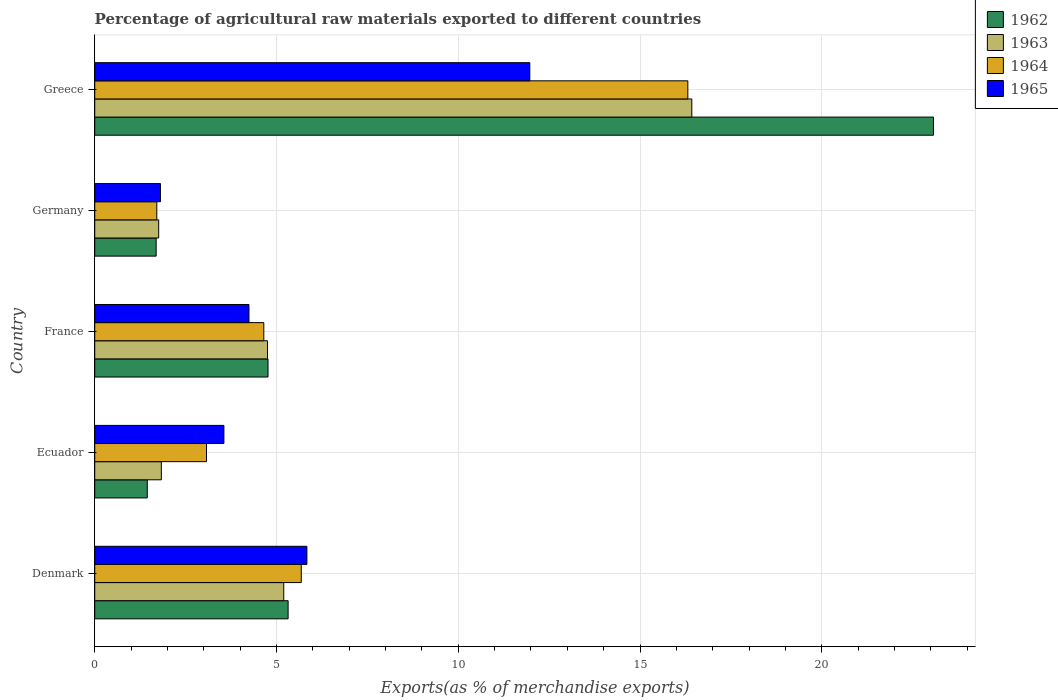How many groups of bars are there?
Give a very brief answer. 5. Are the number of bars on each tick of the Y-axis equal?
Provide a short and direct response. Yes. How many bars are there on the 5th tick from the bottom?
Keep it short and to the point. 4. In how many cases, is the number of bars for a given country not equal to the number of legend labels?
Your answer should be very brief. 0. What is the percentage of exports to different countries in 1965 in Ecuador?
Your answer should be very brief. 3.55. Across all countries, what is the maximum percentage of exports to different countries in 1962?
Offer a very short reply. 23.07. Across all countries, what is the minimum percentage of exports to different countries in 1965?
Your answer should be very brief. 1.81. In which country was the percentage of exports to different countries in 1964 maximum?
Provide a short and direct response. Greece. What is the total percentage of exports to different countries in 1964 in the graph?
Your answer should be very brief. 31.43. What is the difference between the percentage of exports to different countries in 1964 in Denmark and that in Ecuador?
Ensure brevity in your answer.  2.61. What is the difference between the percentage of exports to different countries in 1965 in France and the percentage of exports to different countries in 1964 in Germany?
Ensure brevity in your answer.  2.54. What is the average percentage of exports to different countries in 1965 per country?
Offer a terse response. 5.48. What is the difference between the percentage of exports to different countries in 1964 and percentage of exports to different countries in 1962 in France?
Ensure brevity in your answer.  -0.12. What is the ratio of the percentage of exports to different countries in 1964 in France to that in Germany?
Your response must be concise. 2.72. Is the percentage of exports to different countries in 1965 in Denmark less than that in France?
Provide a succinct answer. No. What is the difference between the highest and the second highest percentage of exports to different countries in 1965?
Provide a short and direct response. 6.13. What is the difference between the highest and the lowest percentage of exports to different countries in 1965?
Ensure brevity in your answer.  10.16. What does the 2nd bar from the top in Greece represents?
Your response must be concise. 1964. How many bars are there?
Offer a terse response. 20. Are all the bars in the graph horizontal?
Ensure brevity in your answer.  Yes. Does the graph contain any zero values?
Offer a very short reply. No. Does the graph contain grids?
Your answer should be compact. Yes. How many legend labels are there?
Keep it short and to the point. 4. How are the legend labels stacked?
Your answer should be very brief. Vertical. What is the title of the graph?
Offer a terse response. Percentage of agricultural raw materials exported to different countries. What is the label or title of the X-axis?
Offer a terse response. Exports(as % of merchandise exports). What is the label or title of the Y-axis?
Offer a terse response. Country. What is the Exports(as % of merchandise exports) of 1962 in Denmark?
Offer a terse response. 5.32. What is the Exports(as % of merchandise exports) in 1963 in Denmark?
Your response must be concise. 5.2. What is the Exports(as % of merchandise exports) in 1964 in Denmark?
Make the answer very short. 5.68. What is the Exports(as % of merchandise exports) in 1965 in Denmark?
Keep it short and to the point. 5.84. What is the Exports(as % of merchandise exports) of 1962 in Ecuador?
Make the answer very short. 1.45. What is the Exports(as % of merchandise exports) in 1963 in Ecuador?
Your answer should be very brief. 1.83. What is the Exports(as % of merchandise exports) of 1964 in Ecuador?
Keep it short and to the point. 3.07. What is the Exports(as % of merchandise exports) of 1965 in Ecuador?
Keep it short and to the point. 3.55. What is the Exports(as % of merchandise exports) in 1962 in France?
Provide a short and direct response. 4.77. What is the Exports(as % of merchandise exports) in 1963 in France?
Ensure brevity in your answer.  4.75. What is the Exports(as % of merchandise exports) of 1964 in France?
Make the answer very short. 4.65. What is the Exports(as % of merchandise exports) in 1965 in France?
Offer a very short reply. 4.24. What is the Exports(as % of merchandise exports) of 1962 in Germany?
Provide a short and direct response. 1.69. What is the Exports(as % of merchandise exports) in 1963 in Germany?
Your answer should be very brief. 1.76. What is the Exports(as % of merchandise exports) of 1964 in Germany?
Ensure brevity in your answer.  1.71. What is the Exports(as % of merchandise exports) of 1965 in Germany?
Provide a short and direct response. 1.81. What is the Exports(as % of merchandise exports) of 1962 in Greece?
Provide a succinct answer. 23.07. What is the Exports(as % of merchandise exports) in 1963 in Greece?
Your response must be concise. 16.43. What is the Exports(as % of merchandise exports) of 1964 in Greece?
Ensure brevity in your answer.  16.32. What is the Exports(as % of merchandise exports) of 1965 in Greece?
Keep it short and to the point. 11.97. Across all countries, what is the maximum Exports(as % of merchandise exports) in 1962?
Offer a terse response. 23.07. Across all countries, what is the maximum Exports(as % of merchandise exports) in 1963?
Provide a succinct answer. 16.43. Across all countries, what is the maximum Exports(as % of merchandise exports) of 1964?
Make the answer very short. 16.32. Across all countries, what is the maximum Exports(as % of merchandise exports) in 1965?
Offer a very short reply. 11.97. Across all countries, what is the minimum Exports(as % of merchandise exports) in 1962?
Provide a succinct answer. 1.45. Across all countries, what is the minimum Exports(as % of merchandise exports) of 1963?
Your answer should be compact. 1.76. Across all countries, what is the minimum Exports(as % of merchandise exports) of 1964?
Your response must be concise. 1.71. Across all countries, what is the minimum Exports(as % of merchandise exports) in 1965?
Your answer should be compact. 1.81. What is the total Exports(as % of merchandise exports) of 1962 in the graph?
Offer a terse response. 36.29. What is the total Exports(as % of merchandise exports) of 1963 in the graph?
Provide a succinct answer. 29.97. What is the total Exports(as % of merchandise exports) in 1964 in the graph?
Keep it short and to the point. 31.43. What is the total Exports(as % of merchandise exports) of 1965 in the graph?
Ensure brevity in your answer.  27.41. What is the difference between the Exports(as % of merchandise exports) in 1962 in Denmark and that in Ecuador?
Ensure brevity in your answer.  3.87. What is the difference between the Exports(as % of merchandise exports) in 1963 in Denmark and that in Ecuador?
Give a very brief answer. 3.37. What is the difference between the Exports(as % of merchandise exports) of 1964 in Denmark and that in Ecuador?
Make the answer very short. 2.61. What is the difference between the Exports(as % of merchandise exports) in 1965 in Denmark and that in Ecuador?
Your answer should be very brief. 2.28. What is the difference between the Exports(as % of merchandise exports) in 1962 in Denmark and that in France?
Make the answer very short. 0.55. What is the difference between the Exports(as % of merchandise exports) of 1963 in Denmark and that in France?
Give a very brief answer. 0.45. What is the difference between the Exports(as % of merchandise exports) of 1964 in Denmark and that in France?
Offer a very short reply. 1.03. What is the difference between the Exports(as % of merchandise exports) in 1965 in Denmark and that in France?
Your response must be concise. 1.59. What is the difference between the Exports(as % of merchandise exports) in 1962 in Denmark and that in Germany?
Make the answer very short. 3.63. What is the difference between the Exports(as % of merchandise exports) of 1963 in Denmark and that in Germany?
Give a very brief answer. 3.44. What is the difference between the Exports(as % of merchandise exports) of 1964 in Denmark and that in Germany?
Your answer should be very brief. 3.97. What is the difference between the Exports(as % of merchandise exports) in 1965 in Denmark and that in Germany?
Ensure brevity in your answer.  4.03. What is the difference between the Exports(as % of merchandise exports) of 1962 in Denmark and that in Greece?
Offer a very short reply. -17.75. What is the difference between the Exports(as % of merchandise exports) of 1963 in Denmark and that in Greece?
Keep it short and to the point. -11.23. What is the difference between the Exports(as % of merchandise exports) of 1964 in Denmark and that in Greece?
Provide a short and direct response. -10.63. What is the difference between the Exports(as % of merchandise exports) of 1965 in Denmark and that in Greece?
Ensure brevity in your answer.  -6.13. What is the difference between the Exports(as % of merchandise exports) of 1962 in Ecuador and that in France?
Give a very brief answer. -3.32. What is the difference between the Exports(as % of merchandise exports) of 1963 in Ecuador and that in France?
Keep it short and to the point. -2.92. What is the difference between the Exports(as % of merchandise exports) of 1964 in Ecuador and that in France?
Keep it short and to the point. -1.58. What is the difference between the Exports(as % of merchandise exports) in 1965 in Ecuador and that in France?
Give a very brief answer. -0.69. What is the difference between the Exports(as % of merchandise exports) in 1962 in Ecuador and that in Germany?
Make the answer very short. -0.24. What is the difference between the Exports(as % of merchandise exports) of 1963 in Ecuador and that in Germany?
Provide a short and direct response. 0.07. What is the difference between the Exports(as % of merchandise exports) in 1964 in Ecuador and that in Germany?
Keep it short and to the point. 1.37. What is the difference between the Exports(as % of merchandise exports) of 1965 in Ecuador and that in Germany?
Your answer should be compact. 1.75. What is the difference between the Exports(as % of merchandise exports) of 1962 in Ecuador and that in Greece?
Offer a very short reply. -21.63. What is the difference between the Exports(as % of merchandise exports) in 1963 in Ecuador and that in Greece?
Offer a terse response. -14.59. What is the difference between the Exports(as % of merchandise exports) in 1964 in Ecuador and that in Greece?
Give a very brief answer. -13.24. What is the difference between the Exports(as % of merchandise exports) of 1965 in Ecuador and that in Greece?
Provide a short and direct response. -8.42. What is the difference between the Exports(as % of merchandise exports) in 1962 in France and that in Germany?
Offer a very short reply. 3.08. What is the difference between the Exports(as % of merchandise exports) in 1963 in France and that in Germany?
Keep it short and to the point. 2.99. What is the difference between the Exports(as % of merchandise exports) in 1964 in France and that in Germany?
Your answer should be compact. 2.94. What is the difference between the Exports(as % of merchandise exports) of 1965 in France and that in Germany?
Make the answer very short. 2.43. What is the difference between the Exports(as % of merchandise exports) of 1962 in France and that in Greece?
Offer a terse response. -18.3. What is the difference between the Exports(as % of merchandise exports) of 1963 in France and that in Greece?
Your answer should be compact. -11.67. What is the difference between the Exports(as % of merchandise exports) in 1964 in France and that in Greece?
Your answer should be very brief. -11.66. What is the difference between the Exports(as % of merchandise exports) in 1965 in France and that in Greece?
Provide a short and direct response. -7.73. What is the difference between the Exports(as % of merchandise exports) in 1962 in Germany and that in Greece?
Ensure brevity in your answer.  -21.38. What is the difference between the Exports(as % of merchandise exports) in 1963 in Germany and that in Greece?
Offer a terse response. -14.67. What is the difference between the Exports(as % of merchandise exports) of 1964 in Germany and that in Greece?
Keep it short and to the point. -14.61. What is the difference between the Exports(as % of merchandise exports) in 1965 in Germany and that in Greece?
Provide a short and direct response. -10.16. What is the difference between the Exports(as % of merchandise exports) in 1962 in Denmark and the Exports(as % of merchandise exports) in 1963 in Ecuador?
Keep it short and to the point. 3.49. What is the difference between the Exports(as % of merchandise exports) of 1962 in Denmark and the Exports(as % of merchandise exports) of 1964 in Ecuador?
Give a very brief answer. 2.25. What is the difference between the Exports(as % of merchandise exports) in 1962 in Denmark and the Exports(as % of merchandise exports) in 1965 in Ecuador?
Make the answer very short. 1.77. What is the difference between the Exports(as % of merchandise exports) of 1963 in Denmark and the Exports(as % of merchandise exports) of 1964 in Ecuador?
Your response must be concise. 2.13. What is the difference between the Exports(as % of merchandise exports) in 1963 in Denmark and the Exports(as % of merchandise exports) in 1965 in Ecuador?
Give a very brief answer. 1.65. What is the difference between the Exports(as % of merchandise exports) in 1964 in Denmark and the Exports(as % of merchandise exports) in 1965 in Ecuador?
Your answer should be compact. 2.13. What is the difference between the Exports(as % of merchandise exports) in 1962 in Denmark and the Exports(as % of merchandise exports) in 1963 in France?
Your answer should be compact. 0.57. What is the difference between the Exports(as % of merchandise exports) in 1962 in Denmark and the Exports(as % of merchandise exports) in 1964 in France?
Make the answer very short. 0.67. What is the difference between the Exports(as % of merchandise exports) of 1962 in Denmark and the Exports(as % of merchandise exports) of 1965 in France?
Keep it short and to the point. 1.08. What is the difference between the Exports(as % of merchandise exports) of 1963 in Denmark and the Exports(as % of merchandise exports) of 1964 in France?
Offer a terse response. 0.55. What is the difference between the Exports(as % of merchandise exports) of 1963 in Denmark and the Exports(as % of merchandise exports) of 1965 in France?
Give a very brief answer. 0.96. What is the difference between the Exports(as % of merchandise exports) in 1964 in Denmark and the Exports(as % of merchandise exports) in 1965 in France?
Your answer should be very brief. 1.44. What is the difference between the Exports(as % of merchandise exports) in 1962 in Denmark and the Exports(as % of merchandise exports) in 1963 in Germany?
Provide a succinct answer. 3.56. What is the difference between the Exports(as % of merchandise exports) in 1962 in Denmark and the Exports(as % of merchandise exports) in 1964 in Germany?
Make the answer very short. 3.61. What is the difference between the Exports(as % of merchandise exports) in 1962 in Denmark and the Exports(as % of merchandise exports) in 1965 in Germany?
Provide a short and direct response. 3.51. What is the difference between the Exports(as % of merchandise exports) of 1963 in Denmark and the Exports(as % of merchandise exports) of 1964 in Germany?
Your response must be concise. 3.49. What is the difference between the Exports(as % of merchandise exports) in 1963 in Denmark and the Exports(as % of merchandise exports) in 1965 in Germany?
Provide a short and direct response. 3.39. What is the difference between the Exports(as % of merchandise exports) in 1964 in Denmark and the Exports(as % of merchandise exports) in 1965 in Germany?
Give a very brief answer. 3.87. What is the difference between the Exports(as % of merchandise exports) in 1962 in Denmark and the Exports(as % of merchandise exports) in 1963 in Greece?
Offer a very short reply. -11.11. What is the difference between the Exports(as % of merchandise exports) in 1962 in Denmark and the Exports(as % of merchandise exports) in 1964 in Greece?
Keep it short and to the point. -11. What is the difference between the Exports(as % of merchandise exports) of 1962 in Denmark and the Exports(as % of merchandise exports) of 1965 in Greece?
Make the answer very short. -6.65. What is the difference between the Exports(as % of merchandise exports) of 1963 in Denmark and the Exports(as % of merchandise exports) of 1964 in Greece?
Make the answer very short. -11.12. What is the difference between the Exports(as % of merchandise exports) of 1963 in Denmark and the Exports(as % of merchandise exports) of 1965 in Greece?
Ensure brevity in your answer.  -6.77. What is the difference between the Exports(as % of merchandise exports) of 1964 in Denmark and the Exports(as % of merchandise exports) of 1965 in Greece?
Offer a very short reply. -6.29. What is the difference between the Exports(as % of merchandise exports) of 1962 in Ecuador and the Exports(as % of merchandise exports) of 1963 in France?
Your answer should be compact. -3.31. What is the difference between the Exports(as % of merchandise exports) of 1962 in Ecuador and the Exports(as % of merchandise exports) of 1964 in France?
Ensure brevity in your answer.  -3.21. What is the difference between the Exports(as % of merchandise exports) of 1962 in Ecuador and the Exports(as % of merchandise exports) of 1965 in France?
Ensure brevity in your answer.  -2.8. What is the difference between the Exports(as % of merchandise exports) in 1963 in Ecuador and the Exports(as % of merchandise exports) in 1964 in France?
Your response must be concise. -2.82. What is the difference between the Exports(as % of merchandise exports) in 1963 in Ecuador and the Exports(as % of merchandise exports) in 1965 in France?
Offer a very short reply. -2.41. What is the difference between the Exports(as % of merchandise exports) in 1964 in Ecuador and the Exports(as % of merchandise exports) in 1965 in France?
Keep it short and to the point. -1.17. What is the difference between the Exports(as % of merchandise exports) of 1962 in Ecuador and the Exports(as % of merchandise exports) of 1963 in Germany?
Offer a terse response. -0.31. What is the difference between the Exports(as % of merchandise exports) in 1962 in Ecuador and the Exports(as % of merchandise exports) in 1964 in Germany?
Provide a short and direct response. -0.26. What is the difference between the Exports(as % of merchandise exports) in 1962 in Ecuador and the Exports(as % of merchandise exports) in 1965 in Germany?
Provide a succinct answer. -0.36. What is the difference between the Exports(as % of merchandise exports) in 1963 in Ecuador and the Exports(as % of merchandise exports) in 1965 in Germany?
Your response must be concise. 0.02. What is the difference between the Exports(as % of merchandise exports) in 1964 in Ecuador and the Exports(as % of merchandise exports) in 1965 in Germany?
Your response must be concise. 1.27. What is the difference between the Exports(as % of merchandise exports) of 1962 in Ecuador and the Exports(as % of merchandise exports) of 1963 in Greece?
Keep it short and to the point. -14.98. What is the difference between the Exports(as % of merchandise exports) of 1962 in Ecuador and the Exports(as % of merchandise exports) of 1964 in Greece?
Offer a very short reply. -14.87. What is the difference between the Exports(as % of merchandise exports) in 1962 in Ecuador and the Exports(as % of merchandise exports) in 1965 in Greece?
Give a very brief answer. -10.52. What is the difference between the Exports(as % of merchandise exports) in 1963 in Ecuador and the Exports(as % of merchandise exports) in 1964 in Greece?
Make the answer very short. -14.48. What is the difference between the Exports(as % of merchandise exports) in 1963 in Ecuador and the Exports(as % of merchandise exports) in 1965 in Greece?
Your answer should be compact. -10.14. What is the difference between the Exports(as % of merchandise exports) of 1964 in Ecuador and the Exports(as % of merchandise exports) of 1965 in Greece?
Keep it short and to the point. -8.89. What is the difference between the Exports(as % of merchandise exports) of 1962 in France and the Exports(as % of merchandise exports) of 1963 in Germany?
Offer a terse response. 3.01. What is the difference between the Exports(as % of merchandise exports) of 1962 in France and the Exports(as % of merchandise exports) of 1964 in Germany?
Offer a terse response. 3.06. What is the difference between the Exports(as % of merchandise exports) of 1962 in France and the Exports(as % of merchandise exports) of 1965 in Germany?
Your response must be concise. 2.96. What is the difference between the Exports(as % of merchandise exports) of 1963 in France and the Exports(as % of merchandise exports) of 1964 in Germany?
Your answer should be very brief. 3.05. What is the difference between the Exports(as % of merchandise exports) of 1963 in France and the Exports(as % of merchandise exports) of 1965 in Germany?
Keep it short and to the point. 2.94. What is the difference between the Exports(as % of merchandise exports) in 1964 in France and the Exports(as % of merchandise exports) in 1965 in Germany?
Give a very brief answer. 2.84. What is the difference between the Exports(as % of merchandise exports) in 1962 in France and the Exports(as % of merchandise exports) in 1963 in Greece?
Provide a succinct answer. -11.66. What is the difference between the Exports(as % of merchandise exports) in 1962 in France and the Exports(as % of merchandise exports) in 1964 in Greece?
Offer a very short reply. -11.55. What is the difference between the Exports(as % of merchandise exports) in 1962 in France and the Exports(as % of merchandise exports) in 1965 in Greece?
Your answer should be compact. -7.2. What is the difference between the Exports(as % of merchandise exports) in 1963 in France and the Exports(as % of merchandise exports) in 1964 in Greece?
Provide a short and direct response. -11.56. What is the difference between the Exports(as % of merchandise exports) in 1963 in France and the Exports(as % of merchandise exports) in 1965 in Greece?
Ensure brevity in your answer.  -7.22. What is the difference between the Exports(as % of merchandise exports) in 1964 in France and the Exports(as % of merchandise exports) in 1965 in Greece?
Your answer should be very brief. -7.32. What is the difference between the Exports(as % of merchandise exports) in 1962 in Germany and the Exports(as % of merchandise exports) in 1963 in Greece?
Give a very brief answer. -14.74. What is the difference between the Exports(as % of merchandise exports) in 1962 in Germany and the Exports(as % of merchandise exports) in 1964 in Greece?
Provide a succinct answer. -14.63. What is the difference between the Exports(as % of merchandise exports) of 1962 in Germany and the Exports(as % of merchandise exports) of 1965 in Greece?
Provide a succinct answer. -10.28. What is the difference between the Exports(as % of merchandise exports) in 1963 in Germany and the Exports(as % of merchandise exports) in 1964 in Greece?
Give a very brief answer. -14.56. What is the difference between the Exports(as % of merchandise exports) of 1963 in Germany and the Exports(as % of merchandise exports) of 1965 in Greece?
Ensure brevity in your answer.  -10.21. What is the difference between the Exports(as % of merchandise exports) of 1964 in Germany and the Exports(as % of merchandise exports) of 1965 in Greece?
Offer a very short reply. -10.26. What is the average Exports(as % of merchandise exports) in 1962 per country?
Provide a short and direct response. 7.26. What is the average Exports(as % of merchandise exports) of 1963 per country?
Offer a very short reply. 5.99. What is the average Exports(as % of merchandise exports) of 1964 per country?
Your answer should be compact. 6.29. What is the average Exports(as % of merchandise exports) of 1965 per country?
Offer a terse response. 5.48. What is the difference between the Exports(as % of merchandise exports) of 1962 and Exports(as % of merchandise exports) of 1963 in Denmark?
Ensure brevity in your answer.  0.12. What is the difference between the Exports(as % of merchandise exports) in 1962 and Exports(as % of merchandise exports) in 1964 in Denmark?
Offer a terse response. -0.36. What is the difference between the Exports(as % of merchandise exports) of 1962 and Exports(as % of merchandise exports) of 1965 in Denmark?
Provide a short and direct response. -0.52. What is the difference between the Exports(as % of merchandise exports) in 1963 and Exports(as % of merchandise exports) in 1964 in Denmark?
Your response must be concise. -0.48. What is the difference between the Exports(as % of merchandise exports) of 1963 and Exports(as % of merchandise exports) of 1965 in Denmark?
Give a very brief answer. -0.64. What is the difference between the Exports(as % of merchandise exports) in 1964 and Exports(as % of merchandise exports) in 1965 in Denmark?
Your response must be concise. -0.15. What is the difference between the Exports(as % of merchandise exports) of 1962 and Exports(as % of merchandise exports) of 1963 in Ecuador?
Make the answer very short. -0.39. What is the difference between the Exports(as % of merchandise exports) of 1962 and Exports(as % of merchandise exports) of 1964 in Ecuador?
Keep it short and to the point. -1.63. What is the difference between the Exports(as % of merchandise exports) in 1962 and Exports(as % of merchandise exports) in 1965 in Ecuador?
Your answer should be compact. -2.11. What is the difference between the Exports(as % of merchandise exports) in 1963 and Exports(as % of merchandise exports) in 1964 in Ecuador?
Make the answer very short. -1.24. What is the difference between the Exports(as % of merchandise exports) of 1963 and Exports(as % of merchandise exports) of 1965 in Ecuador?
Your answer should be very brief. -1.72. What is the difference between the Exports(as % of merchandise exports) in 1964 and Exports(as % of merchandise exports) in 1965 in Ecuador?
Your answer should be very brief. -0.48. What is the difference between the Exports(as % of merchandise exports) in 1962 and Exports(as % of merchandise exports) in 1963 in France?
Provide a short and direct response. 0.01. What is the difference between the Exports(as % of merchandise exports) of 1962 and Exports(as % of merchandise exports) of 1964 in France?
Your answer should be very brief. 0.12. What is the difference between the Exports(as % of merchandise exports) of 1962 and Exports(as % of merchandise exports) of 1965 in France?
Provide a succinct answer. 0.52. What is the difference between the Exports(as % of merchandise exports) in 1963 and Exports(as % of merchandise exports) in 1964 in France?
Your answer should be very brief. 0.1. What is the difference between the Exports(as % of merchandise exports) in 1963 and Exports(as % of merchandise exports) in 1965 in France?
Your answer should be very brief. 0.51. What is the difference between the Exports(as % of merchandise exports) of 1964 and Exports(as % of merchandise exports) of 1965 in France?
Make the answer very short. 0.41. What is the difference between the Exports(as % of merchandise exports) of 1962 and Exports(as % of merchandise exports) of 1963 in Germany?
Offer a very short reply. -0.07. What is the difference between the Exports(as % of merchandise exports) in 1962 and Exports(as % of merchandise exports) in 1964 in Germany?
Provide a succinct answer. -0.02. What is the difference between the Exports(as % of merchandise exports) in 1962 and Exports(as % of merchandise exports) in 1965 in Germany?
Ensure brevity in your answer.  -0.12. What is the difference between the Exports(as % of merchandise exports) in 1963 and Exports(as % of merchandise exports) in 1964 in Germany?
Provide a short and direct response. 0.05. What is the difference between the Exports(as % of merchandise exports) of 1963 and Exports(as % of merchandise exports) of 1965 in Germany?
Keep it short and to the point. -0.05. What is the difference between the Exports(as % of merchandise exports) of 1964 and Exports(as % of merchandise exports) of 1965 in Germany?
Offer a terse response. -0.1. What is the difference between the Exports(as % of merchandise exports) in 1962 and Exports(as % of merchandise exports) in 1963 in Greece?
Give a very brief answer. 6.65. What is the difference between the Exports(as % of merchandise exports) in 1962 and Exports(as % of merchandise exports) in 1964 in Greece?
Ensure brevity in your answer.  6.76. What is the difference between the Exports(as % of merchandise exports) in 1962 and Exports(as % of merchandise exports) in 1965 in Greece?
Your answer should be compact. 11.1. What is the difference between the Exports(as % of merchandise exports) in 1963 and Exports(as % of merchandise exports) in 1964 in Greece?
Give a very brief answer. 0.11. What is the difference between the Exports(as % of merchandise exports) of 1963 and Exports(as % of merchandise exports) of 1965 in Greece?
Provide a succinct answer. 4.46. What is the difference between the Exports(as % of merchandise exports) of 1964 and Exports(as % of merchandise exports) of 1965 in Greece?
Make the answer very short. 4.35. What is the ratio of the Exports(as % of merchandise exports) in 1962 in Denmark to that in Ecuador?
Give a very brief answer. 3.68. What is the ratio of the Exports(as % of merchandise exports) in 1963 in Denmark to that in Ecuador?
Provide a succinct answer. 2.84. What is the ratio of the Exports(as % of merchandise exports) of 1964 in Denmark to that in Ecuador?
Provide a short and direct response. 1.85. What is the ratio of the Exports(as % of merchandise exports) in 1965 in Denmark to that in Ecuador?
Your answer should be very brief. 1.64. What is the ratio of the Exports(as % of merchandise exports) in 1962 in Denmark to that in France?
Provide a succinct answer. 1.12. What is the ratio of the Exports(as % of merchandise exports) in 1963 in Denmark to that in France?
Offer a terse response. 1.09. What is the ratio of the Exports(as % of merchandise exports) in 1964 in Denmark to that in France?
Offer a very short reply. 1.22. What is the ratio of the Exports(as % of merchandise exports) of 1965 in Denmark to that in France?
Keep it short and to the point. 1.38. What is the ratio of the Exports(as % of merchandise exports) in 1962 in Denmark to that in Germany?
Provide a short and direct response. 3.15. What is the ratio of the Exports(as % of merchandise exports) of 1963 in Denmark to that in Germany?
Offer a terse response. 2.96. What is the ratio of the Exports(as % of merchandise exports) in 1964 in Denmark to that in Germany?
Give a very brief answer. 3.33. What is the ratio of the Exports(as % of merchandise exports) of 1965 in Denmark to that in Germany?
Make the answer very short. 3.23. What is the ratio of the Exports(as % of merchandise exports) in 1962 in Denmark to that in Greece?
Offer a terse response. 0.23. What is the ratio of the Exports(as % of merchandise exports) of 1963 in Denmark to that in Greece?
Give a very brief answer. 0.32. What is the ratio of the Exports(as % of merchandise exports) of 1964 in Denmark to that in Greece?
Offer a terse response. 0.35. What is the ratio of the Exports(as % of merchandise exports) of 1965 in Denmark to that in Greece?
Give a very brief answer. 0.49. What is the ratio of the Exports(as % of merchandise exports) in 1962 in Ecuador to that in France?
Offer a very short reply. 0.3. What is the ratio of the Exports(as % of merchandise exports) in 1963 in Ecuador to that in France?
Your answer should be very brief. 0.39. What is the ratio of the Exports(as % of merchandise exports) in 1964 in Ecuador to that in France?
Your response must be concise. 0.66. What is the ratio of the Exports(as % of merchandise exports) of 1965 in Ecuador to that in France?
Your answer should be very brief. 0.84. What is the ratio of the Exports(as % of merchandise exports) in 1962 in Ecuador to that in Germany?
Your answer should be compact. 0.86. What is the ratio of the Exports(as % of merchandise exports) in 1963 in Ecuador to that in Germany?
Keep it short and to the point. 1.04. What is the ratio of the Exports(as % of merchandise exports) in 1964 in Ecuador to that in Germany?
Give a very brief answer. 1.8. What is the ratio of the Exports(as % of merchandise exports) of 1965 in Ecuador to that in Germany?
Give a very brief answer. 1.96. What is the ratio of the Exports(as % of merchandise exports) in 1962 in Ecuador to that in Greece?
Your answer should be very brief. 0.06. What is the ratio of the Exports(as % of merchandise exports) in 1963 in Ecuador to that in Greece?
Provide a short and direct response. 0.11. What is the ratio of the Exports(as % of merchandise exports) of 1964 in Ecuador to that in Greece?
Your response must be concise. 0.19. What is the ratio of the Exports(as % of merchandise exports) of 1965 in Ecuador to that in Greece?
Provide a succinct answer. 0.3. What is the ratio of the Exports(as % of merchandise exports) of 1962 in France to that in Germany?
Your response must be concise. 2.82. What is the ratio of the Exports(as % of merchandise exports) in 1963 in France to that in Germany?
Offer a terse response. 2.7. What is the ratio of the Exports(as % of merchandise exports) in 1964 in France to that in Germany?
Your answer should be compact. 2.72. What is the ratio of the Exports(as % of merchandise exports) in 1965 in France to that in Germany?
Provide a short and direct response. 2.35. What is the ratio of the Exports(as % of merchandise exports) of 1962 in France to that in Greece?
Your answer should be very brief. 0.21. What is the ratio of the Exports(as % of merchandise exports) in 1963 in France to that in Greece?
Ensure brevity in your answer.  0.29. What is the ratio of the Exports(as % of merchandise exports) in 1964 in France to that in Greece?
Provide a short and direct response. 0.29. What is the ratio of the Exports(as % of merchandise exports) in 1965 in France to that in Greece?
Your answer should be very brief. 0.35. What is the ratio of the Exports(as % of merchandise exports) of 1962 in Germany to that in Greece?
Your answer should be very brief. 0.07. What is the ratio of the Exports(as % of merchandise exports) in 1963 in Germany to that in Greece?
Provide a short and direct response. 0.11. What is the ratio of the Exports(as % of merchandise exports) of 1964 in Germany to that in Greece?
Provide a succinct answer. 0.1. What is the ratio of the Exports(as % of merchandise exports) in 1965 in Germany to that in Greece?
Offer a very short reply. 0.15. What is the difference between the highest and the second highest Exports(as % of merchandise exports) in 1962?
Provide a short and direct response. 17.75. What is the difference between the highest and the second highest Exports(as % of merchandise exports) of 1963?
Offer a terse response. 11.23. What is the difference between the highest and the second highest Exports(as % of merchandise exports) of 1964?
Your answer should be compact. 10.63. What is the difference between the highest and the second highest Exports(as % of merchandise exports) in 1965?
Ensure brevity in your answer.  6.13. What is the difference between the highest and the lowest Exports(as % of merchandise exports) of 1962?
Provide a short and direct response. 21.63. What is the difference between the highest and the lowest Exports(as % of merchandise exports) of 1963?
Keep it short and to the point. 14.67. What is the difference between the highest and the lowest Exports(as % of merchandise exports) in 1964?
Give a very brief answer. 14.61. What is the difference between the highest and the lowest Exports(as % of merchandise exports) of 1965?
Keep it short and to the point. 10.16. 